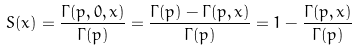Convert formula to latex. <formula><loc_0><loc_0><loc_500><loc_500>S ( x ) = \frac { \Gamma ( p , 0 , x ) } { \Gamma ( p ) } = \frac { \Gamma ( p ) - \Gamma ( p , x ) } { \Gamma ( p ) } = 1 - \frac { \Gamma ( p , x ) } { \Gamma ( p ) }</formula> 